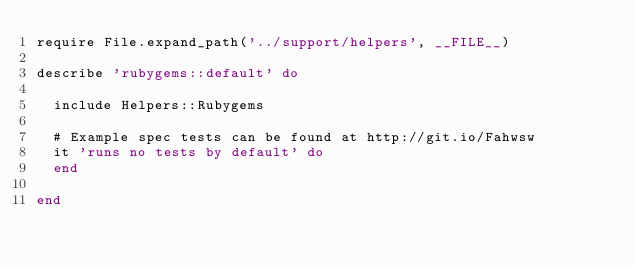<code> <loc_0><loc_0><loc_500><loc_500><_Ruby_>require File.expand_path('../support/helpers', __FILE__)

describe 'rubygems::default' do

  include Helpers::Rubygems

  # Example spec tests can be found at http://git.io/Fahwsw
  it 'runs no tests by default' do
  end

end
</code> 